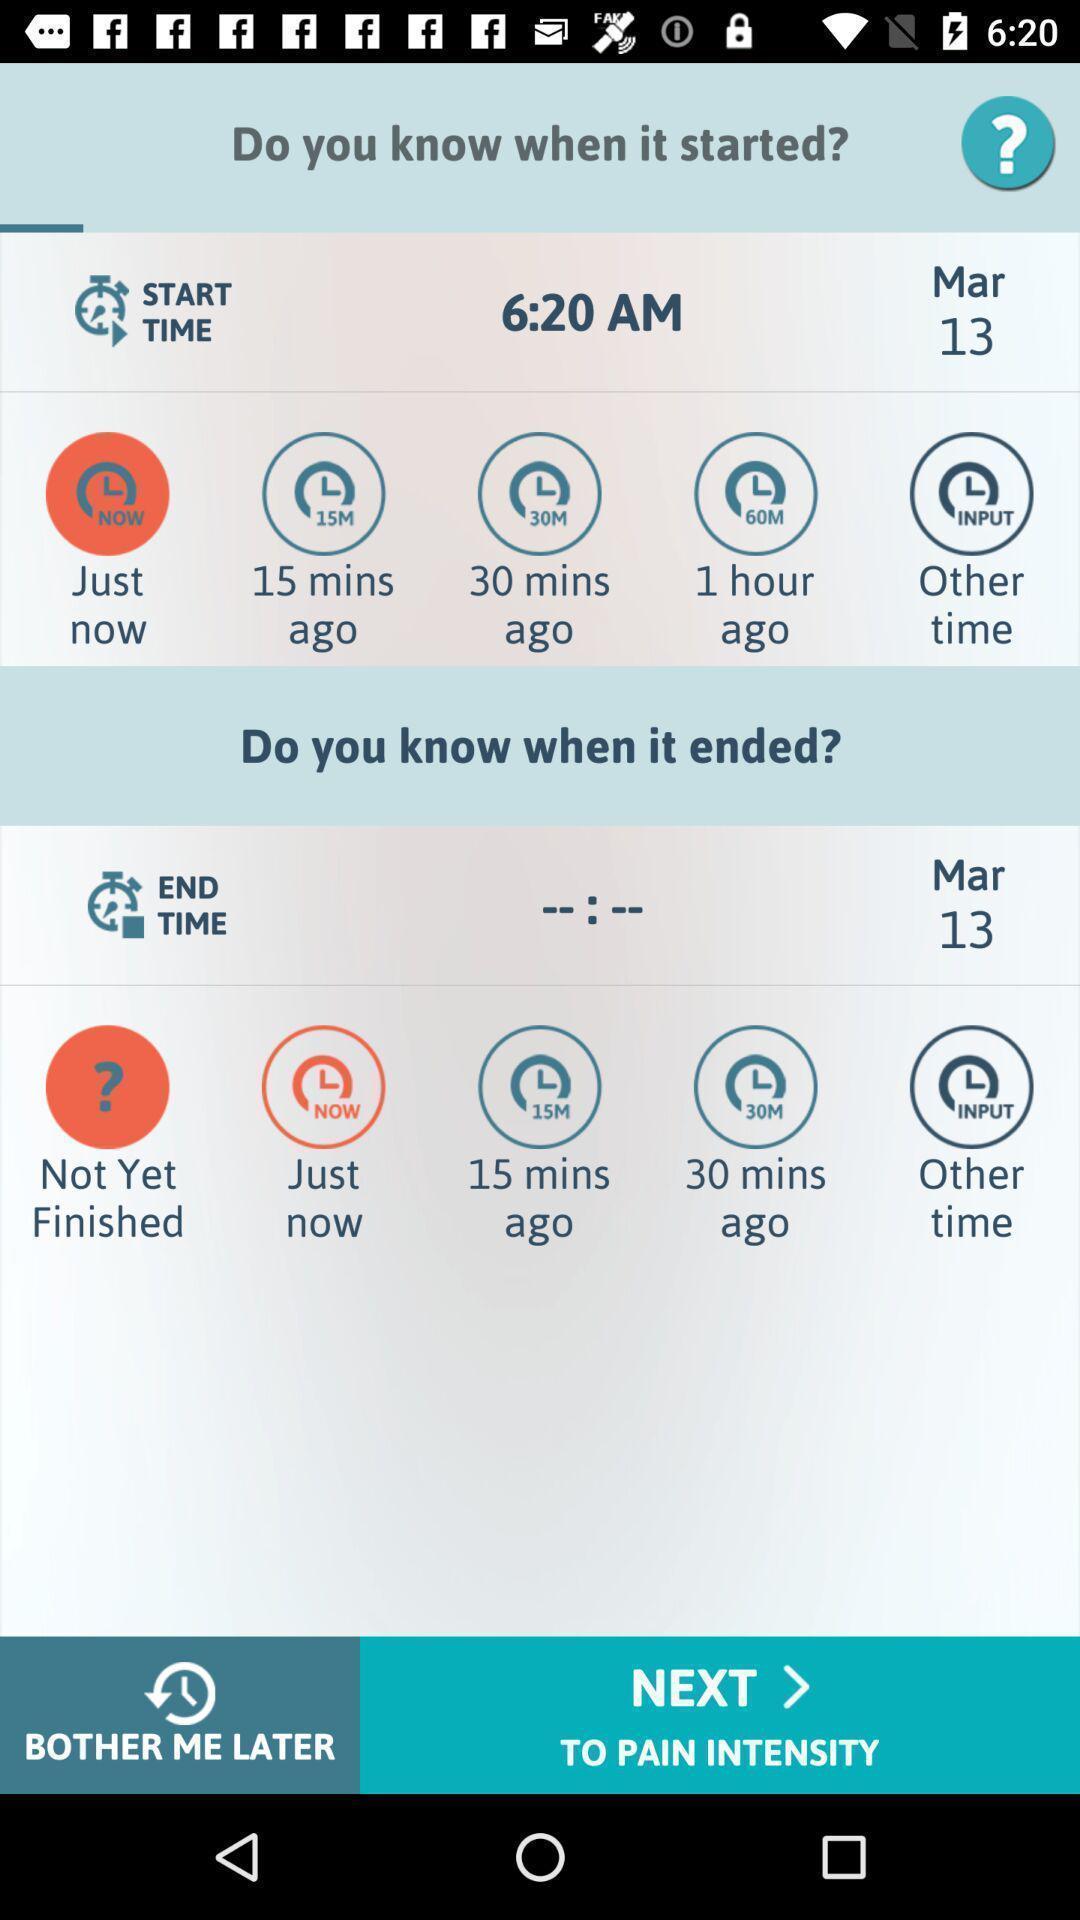What can you discern from this picture? Start time and end time options. 